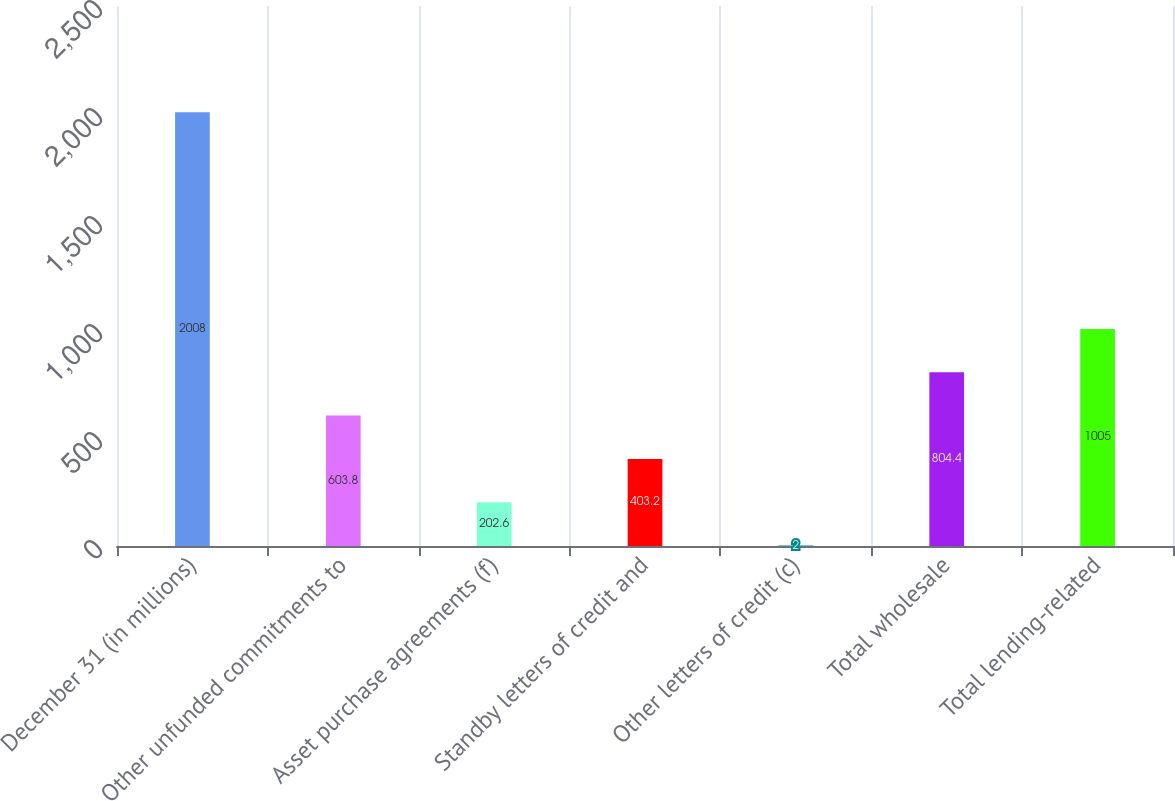Convert chart. <chart><loc_0><loc_0><loc_500><loc_500><bar_chart><fcel>December 31 (in millions)<fcel>Other unfunded commitments to<fcel>Asset purchase agreements (f)<fcel>Standby letters of credit and<fcel>Other letters of credit (c)<fcel>Total wholesale<fcel>Total lending-related<nl><fcel>2008<fcel>603.8<fcel>202.6<fcel>403.2<fcel>2<fcel>804.4<fcel>1005<nl></chart> 